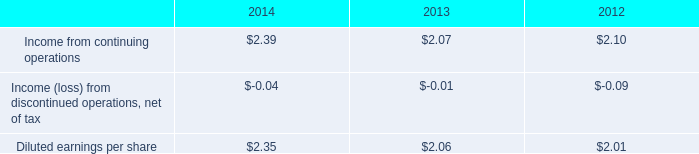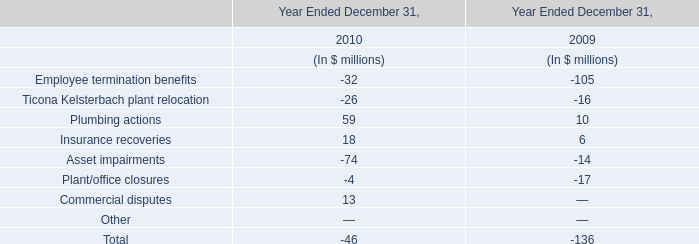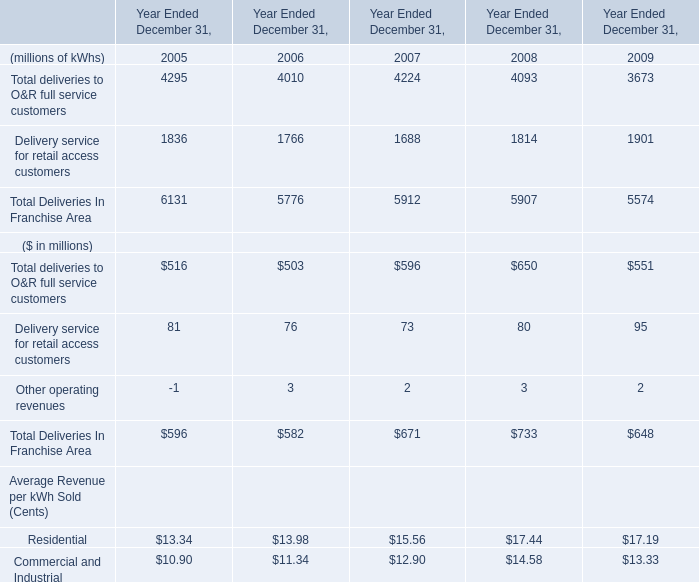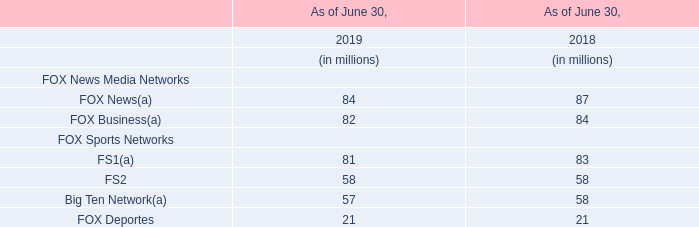What is the sum of the Total Deliveries In Franchise Area in the years where Delivery service for retail access customers is greater than 1900? (in million) 
Answer: 5574. 